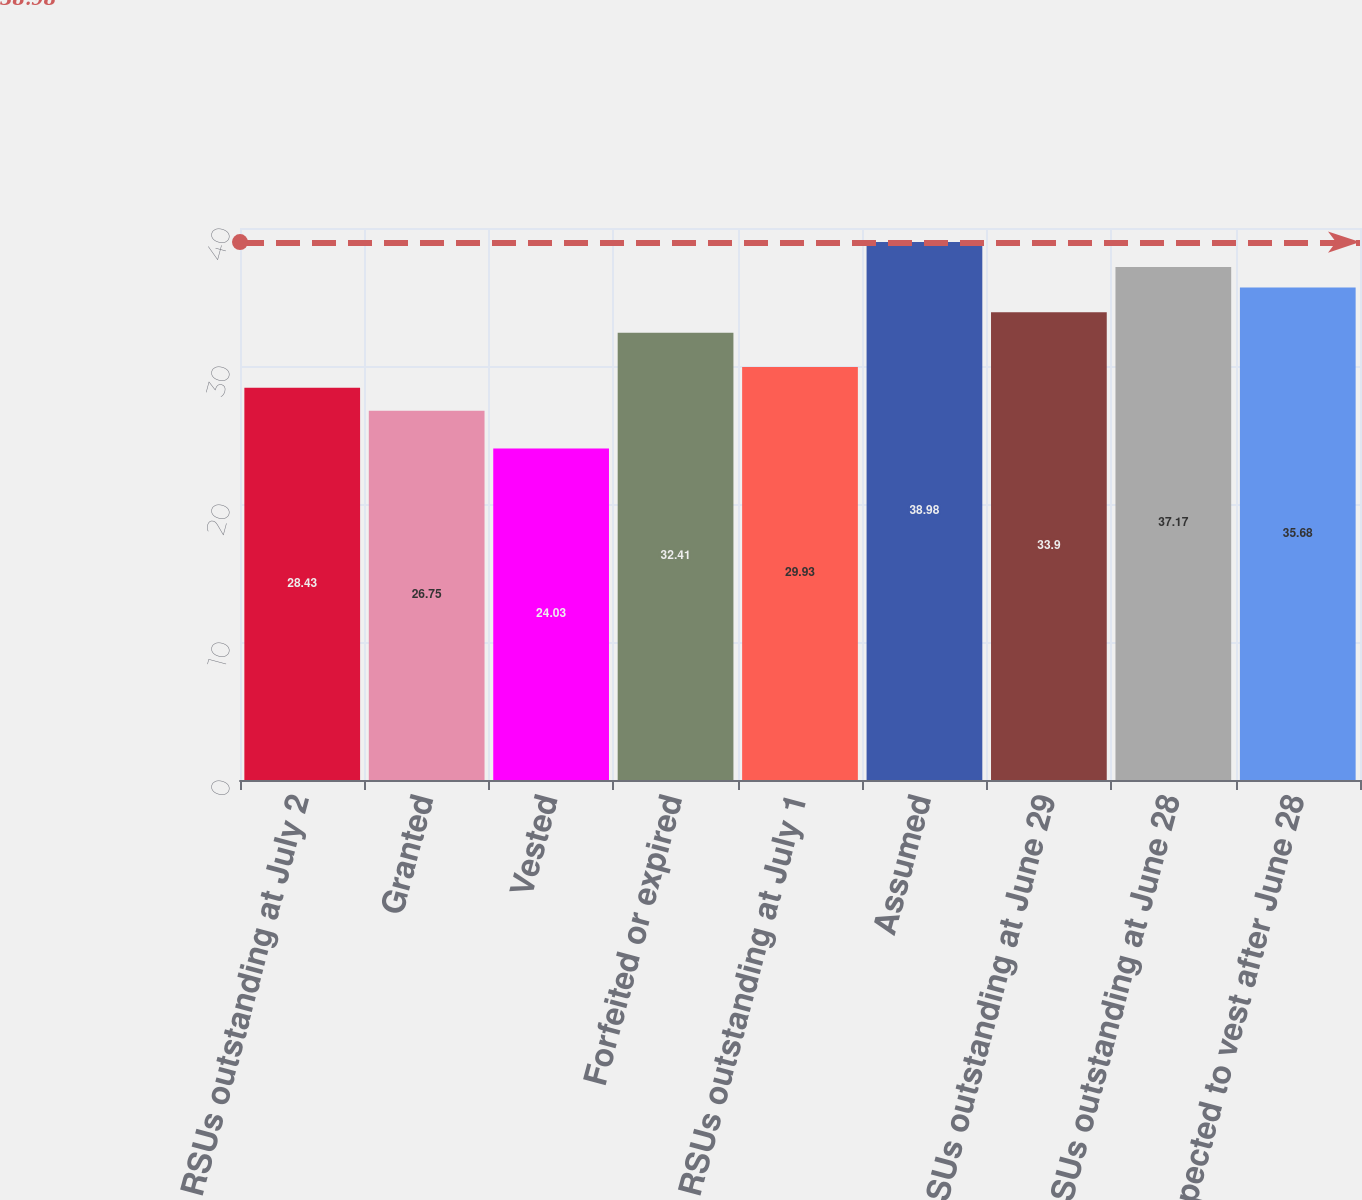<chart> <loc_0><loc_0><loc_500><loc_500><bar_chart><fcel>RSUs outstanding at July 2<fcel>Granted<fcel>Vested<fcel>Forfeited or expired<fcel>RSUs outstanding at July 1<fcel>Assumed<fcel>RSUs outstanding at June 29<fcel>RSUs outstanding at June 28<fcel>Expected to vest after June 28<nl><fcel>28.43<fcel>26.75<fcel>24.03<fcel>32.41<fcel>29.93<fcel>38.98<fcel>33.9<fcel>37.17<fcel>35.68<nl></chart> 